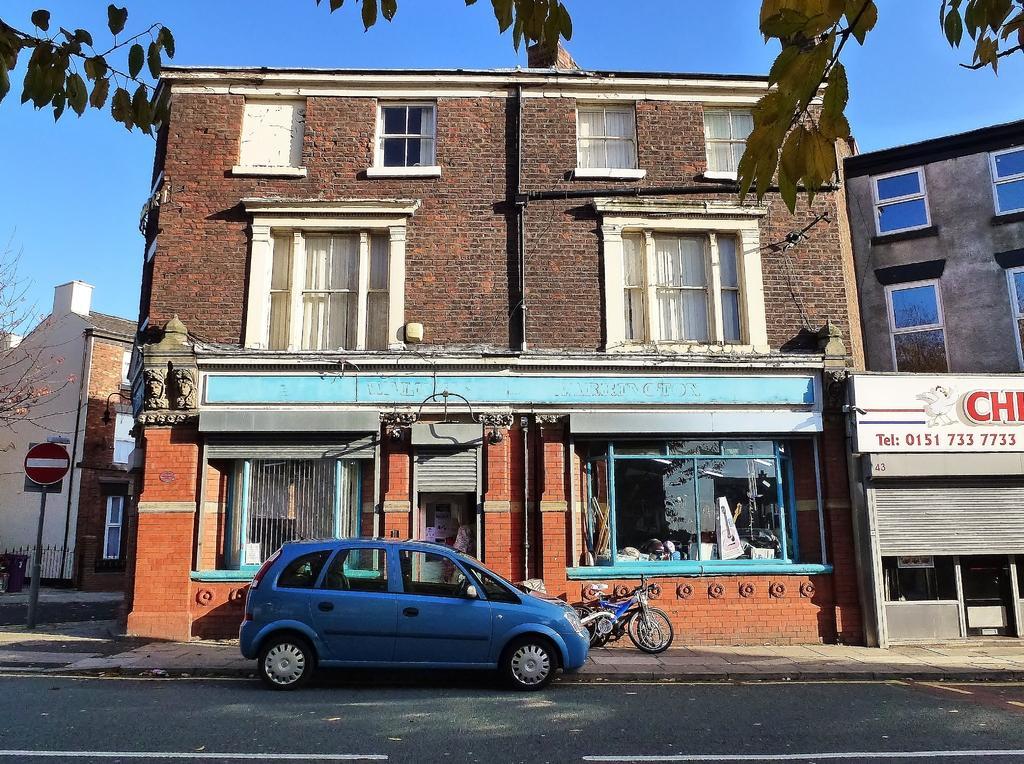Describe this image in one or two sentences. In this picture we can see a car on the road, bicycle, buildings, boards, tree and pole. In the background of the image we can see the sky. At the top of the image we can see leaves. 